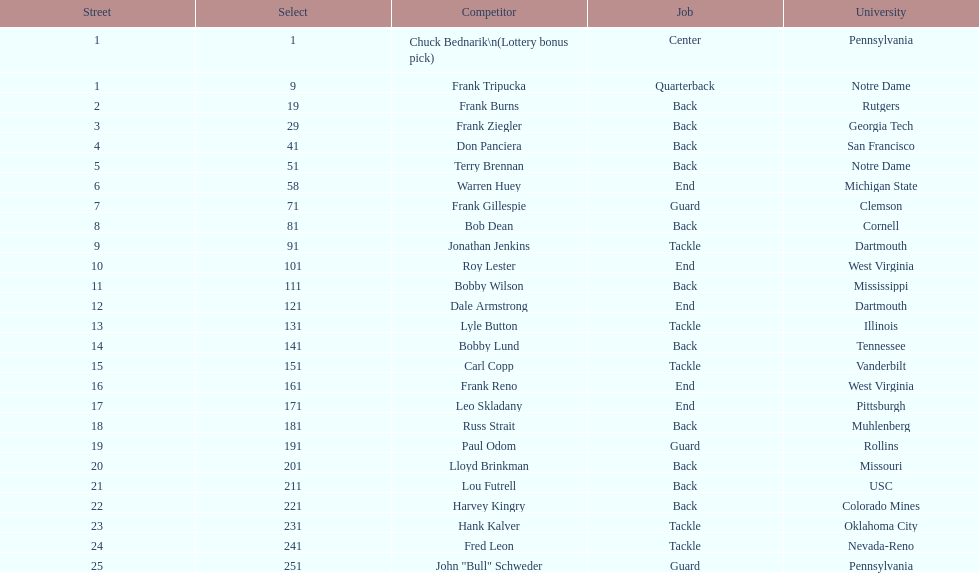Who was picked after frank burns? Frank Ziegler. 